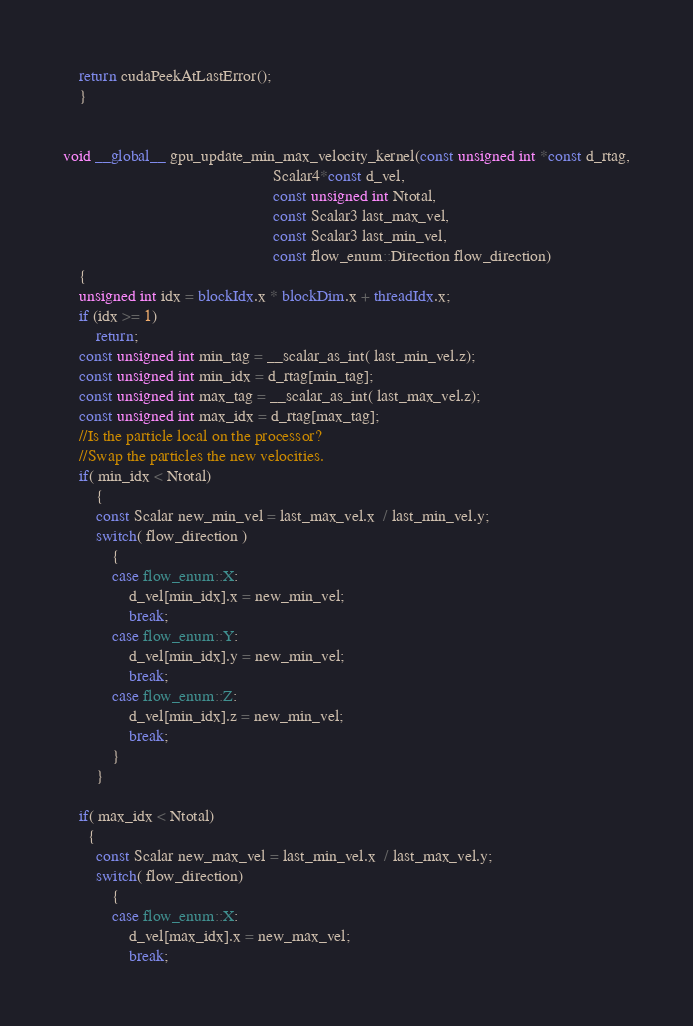Convert code to text. <code><loc_0><loc_0><loc_500><loc_500><_Cuda_>

    return cudaPeekAtLastError();
    }


void __global__ gpu_update_min_max_velocity_kernel(const unsigned int *const d_rtag,
                                                   Scalar4*const d_vel,
                                                   const unsigned int Ntotal,
                                                   const Scalar3 last_max_vel,
                                                   const Scalar3 last_min_vel,
                                                   const flow_enum::Direction flow_direction)
    {
    unsigned int idx = blockIdx.x * blockDim.x + threadIdx.x;
    if (idx >= 1)
        return;
    const unsigned int min_tag = __scalar_as_int( last_min_vel.z);
    const unsigned int min_idx = d_rtag[min_tag];
    const unsigned int max_tag = __scalar_as_int( last_max_vel.z);
    const unsigned int max_idx = d_rtag[max_tag];
    //Is the particle local on the processor?
    //Swap the particles the new velocities.
    if( min_idx < Ntotal)
        {
        const Scalar new_min_vel = last_max_vel.x  / last_min_vel.y;
        switch( flow_direction )
            {
            case flow_enum::X:
                d_vel[min_idx].x = new_min_vel;
                break;
            case flow_enum::Y:
                d_vel[min_idx].y = new_min_vel;
                break;
            case flow_enum::Z:
                d_vel[min_idx].z = new_min_vel;
                break;
            }
        }

    if( max_idx < Ntotal)
      {
        const Scalar new_max_vel = last_min_vel.x  / last_max_vel.y;
        switch( flow_direction)
            {
            case flow_enum::X:
                d_vel[max_idx].x = new_max_vel;
                break;</code> 